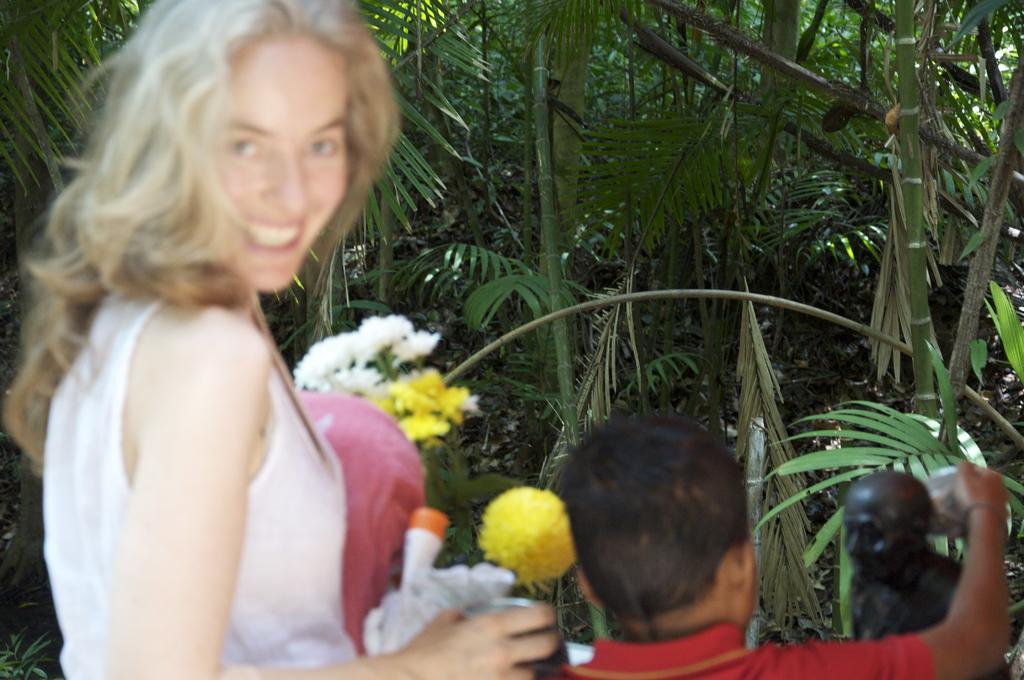How would you summarize this image in a sentence or two? In this image I can see a woman wearing white colored dress is standing and holding few objects in her hand. I can see another person wearing red colored dress, a black colored statue, few trees and few flowers which are white and yellow in color in the background. 